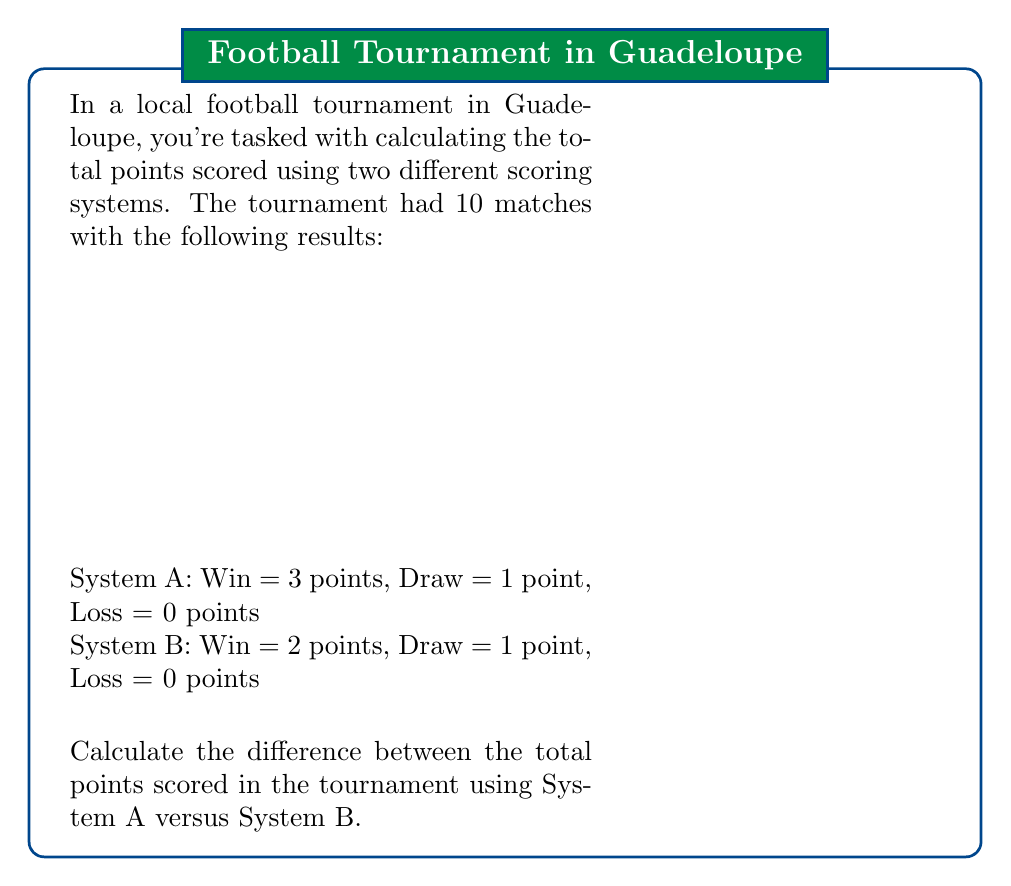Give your solution to this math problem. Let's approach this step-by-step:

1) First, let's count the number of wins, draws, and losses:
   Wins: 7 (Matches 1, 3, 4, 6, 8, 9, 10)
   Draws: 3 (Matches 2, 5, 7)
   Losses: 7 (the losing teams in the 7 wins)

2) Now, let's calculate the total points for System A:
   $$\text{Total A} = (3 \times \text{Wins}) + (1 \times \text{Draws}) + (0 \times \text{Losses})$$
   $$\text{Total A} = (3 \times 7) + (1 \times 3) + (0 \times 7) = 21 + 3 + 0 = 24$$

3) Next, let's calculate the total points for System B:
   $$\text{Total B} = (2 \times \text{Wins}) + (1 \times \text{Draws}) + (0 \times \text{Losses})$$
   $$\text{Total B} = (2 \times 7) + (1 \times 3) + (0 \times 7) = 14 + 3 + 0 = 17$$

4) Finally, let's calculate the difference:
   $$\text{Difference} = \text{Total A} - \text{Total B} = 24 - 17 = 7$$

Therefore, the difference between the total points scored using System A versus System B is 7 points.
Answer: 7 points 